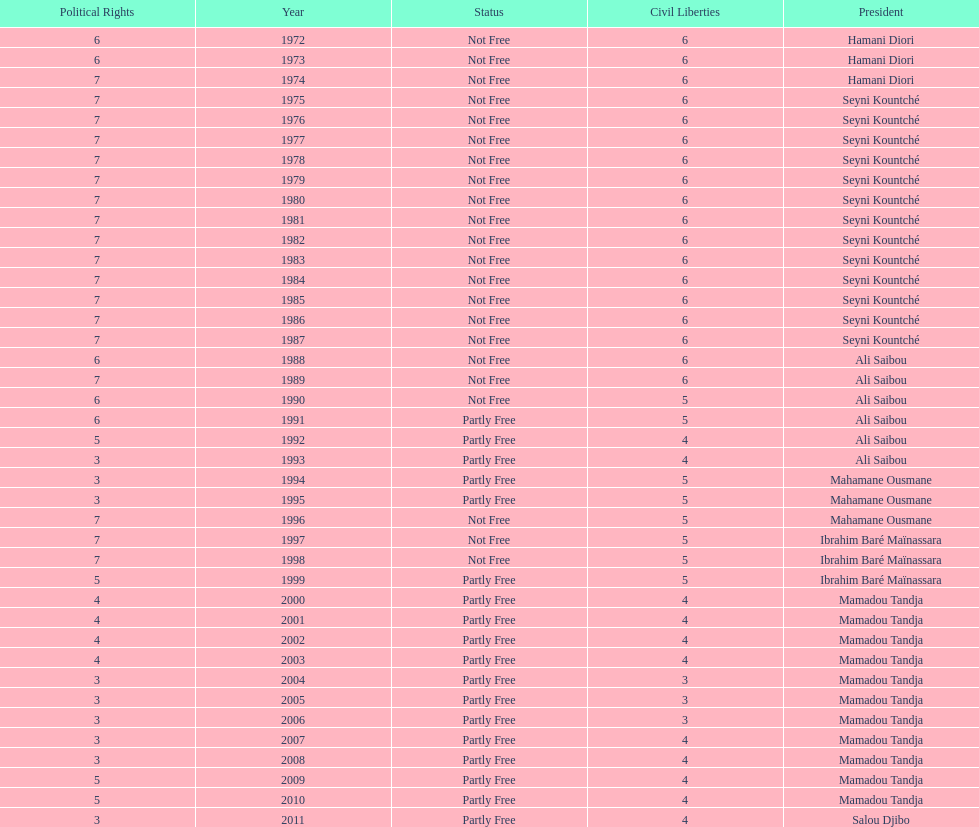How many times was the political rights listed as seven? 18. 